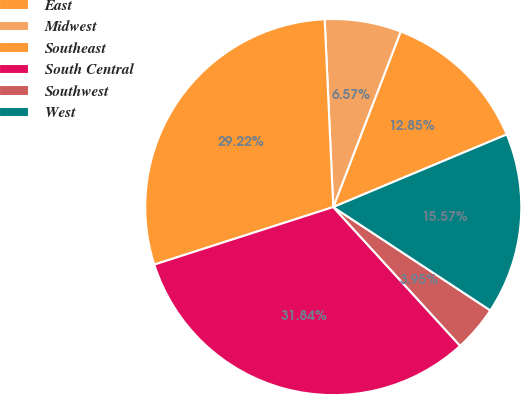Convert chart to OTSL. <chart><loc_0><loc_0><loc_500><loc_500><pie_chart><fcel>East<fcel>Midwest<fcel>Southeast<fcel>South Central<fcel>Southwest<fcel>West<nl><fcel>12.85%<fcel>6.57%<fcel>29.22%<fcel>31.84%<fcel>3.95%<fcel>15.57%<nl></chart> 